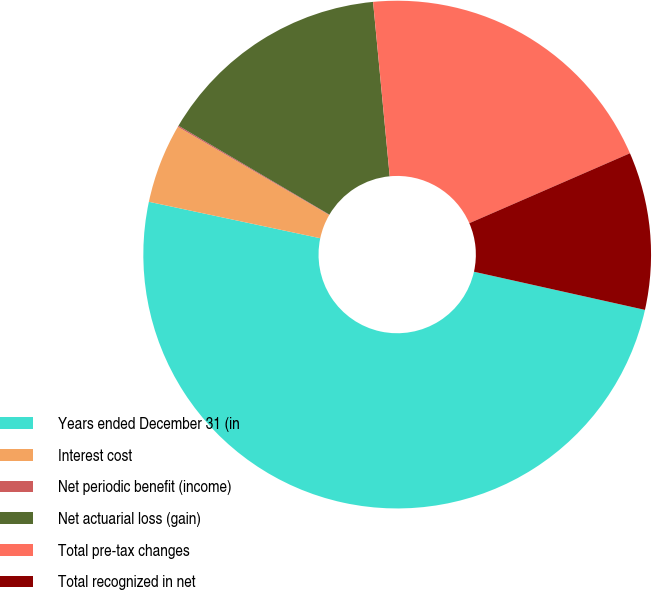Convert chart. <chart><loc_0><loc_0><loc_500><loc_500><pie_chart><fcel>Years ended December 31 (in<fcel>Interest cost<fcel>Net periodic benefit (income)<fcel>Net actuarial loss (gain)<fcel>Total pre-tax changes<fcel>Total recognized in net<nl><fcel>49.84%<fcel>5.06%<fcel>0.08%<fcel>15.01%<fcel>19.98%<fcel>10.03%<nl></chart> 